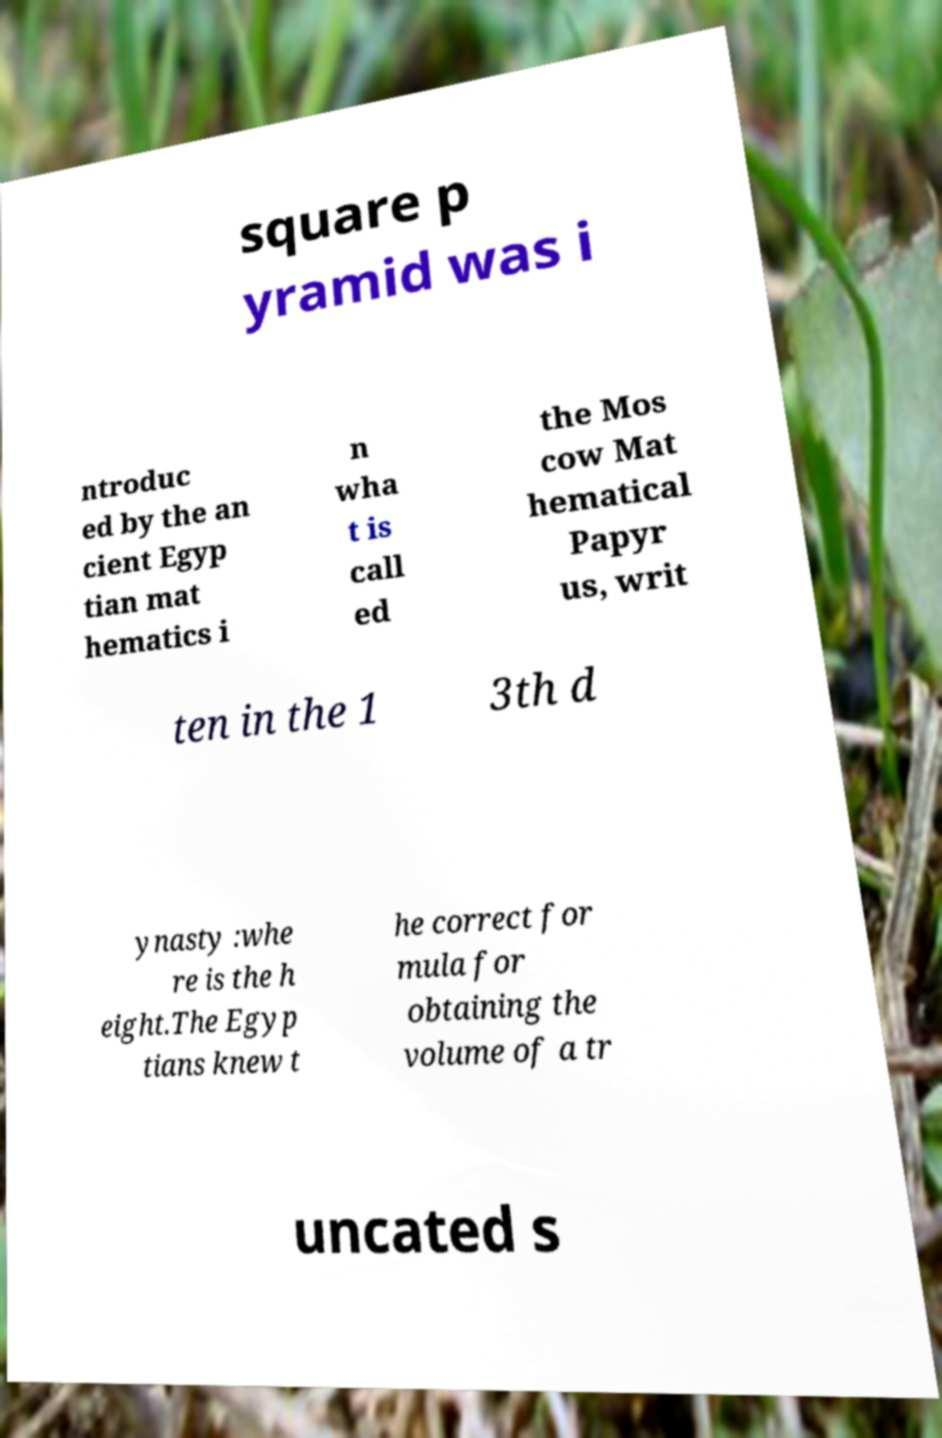I need the written content from this picture converted into text. Can you do that? square p yramid was i ntroduc ed by the an cient Egyp tian mat hematics i n wha t is call ed the Mos cow Mat hematical Papyr us, writ ten in the 1 3th d ynasty :whe re is the h eight.The Egyp tians knew t he correct for mula for obtaining the volume of a tr uncated s 